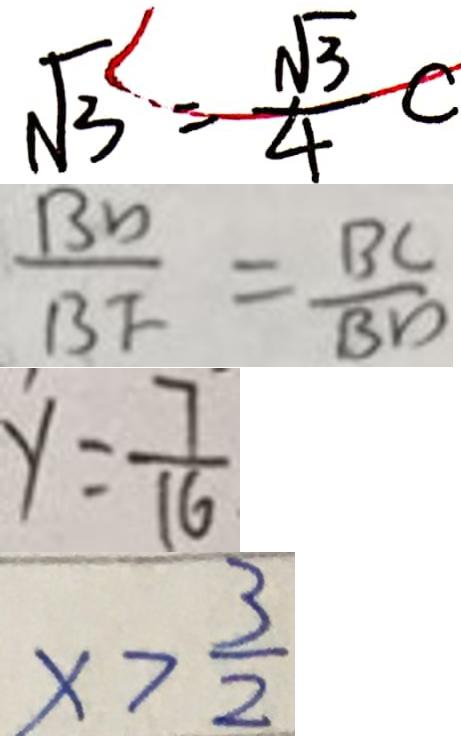<formula> <loc_0><loc_0><loc_500><loc_500>\sqrt { 3 } < \frac { \sqrt { 3 } } { 4 } c 
 \frac { B D } { B F } = \frac { B C } { B D } 
 y = \frac { 7 } { 1 6 } 
 x > \frac { 3 } { 2 }</formula> 